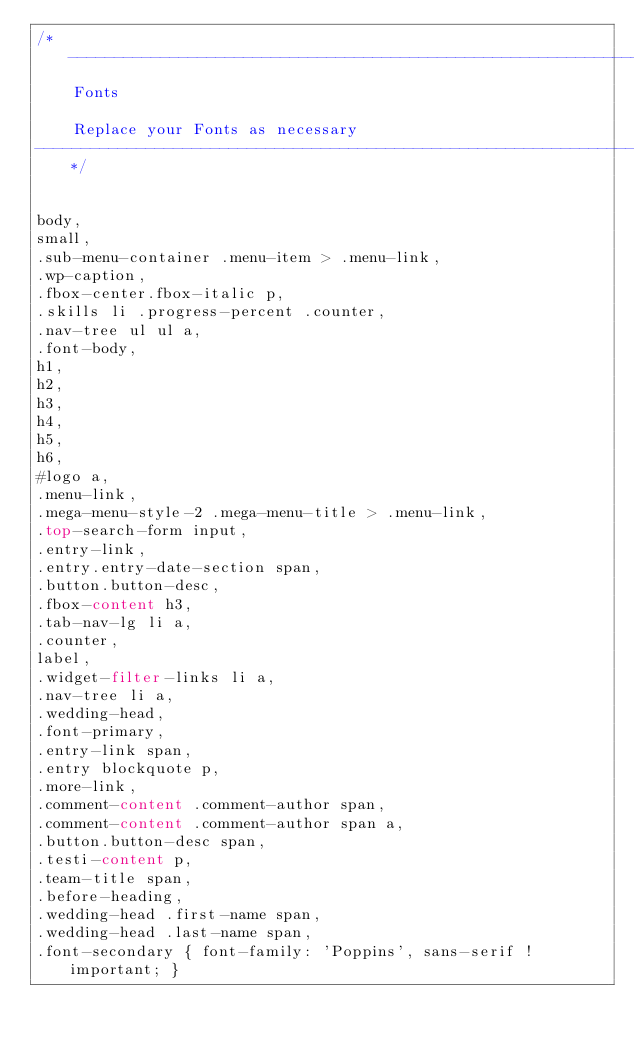<code> <loc_0><loc_0><loc_500><loc_500><_CSS_>/* ----------------------------------------------------------------
    Fonts

    Replace your Fonts as necessary
-----------------------------------------------------------------*/


body,
small,
.sub-menu-container .menu-item > .menu-link,
.wp-caption,
.fbox-center.fbox-italic p,
.skills li .progress-percent .counter,
.nav-tree ul ul a,
.font-body,
h1,
h2,
h3,
h4,
h5,
h6,
#logo a,
.menu-link,
.mega-menu-style-2 .mega-menu-title > .menu-link,
.top-search-form input,
.entry-link,
.entry.entry-date-section span,
.button.button-desc,
.fbox-content h3,
.tab-nav-lg li a,
.counter,
label,
.widget-filter-links li a,
.nav-tree li a,
.wedding-head,
.font-primary,
.entry-link span,
.entry blockquote p,
.more-link,
.comment-content .comment-author span,
.comment-content .comment-author span a,
.button.button-desc span,
.testi-content p,
.team-title span,
.before-heading,
.wedding-head .first-name span,
.wedding-head .last-name span,
.font-secondary { font-family: 'Poppins', sans-serif !important; }

</code> 